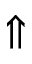Convert formula to latex. <formula><loc_0><loc_0><loc_500><loc_500>\Uparrow</formula> 